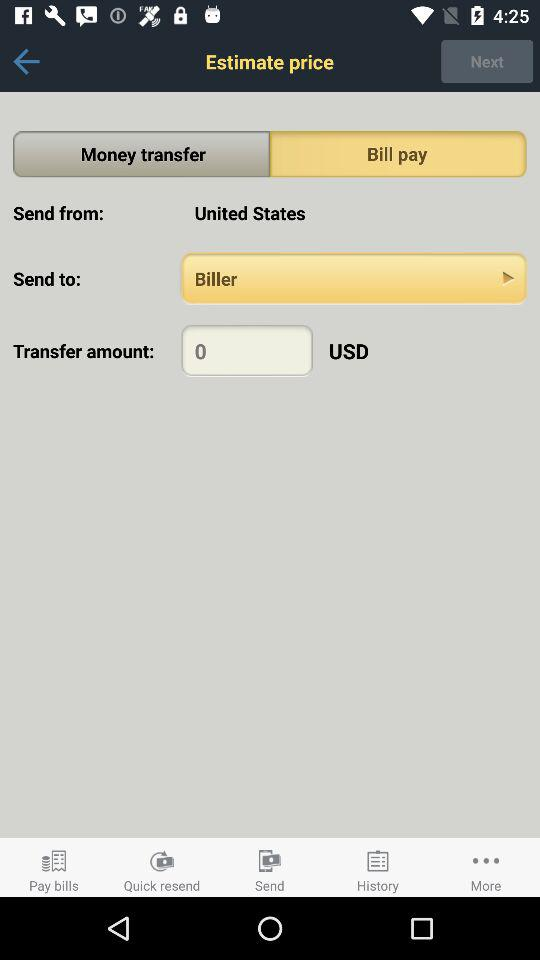What's the transfer amount? The transfer amount is 0 USD. 